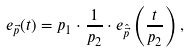<formula> <loc_0><loc_0><loc_500><loc_500>e _ { \vec { p } } ( t ) = p _ { 1 } \cdot \frac { 1 } { p _ { 2 } } \cdot e _ { \hat { \vec { p } } } \left ( \frac { t } { p _ { 2 } } \right ) ,</formula> 